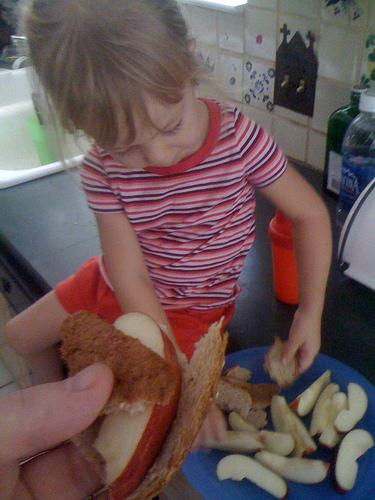Question: when will the girl finish the apples?
Choices:
A. When she's satisfied.
B. After dinner.
C. After school.
D. When her mom reminds her.
Answer with the letter. Answer: A Question: where are the apples?
Choices:
A. On the counter.
B. On the plate.
C. In the bin.
D. On the table.
Answer with the letter. Answer: B Question: who is eating the apples?
Choices:
A. The worms.
B. The pigs.
C. An old woman.
D. A child.
Answer with the letter. Answer: D Question: why are the apples sliced?
Choices:
A. To use in a pie.
B. For a snack.
C. To cook them for an ice cream topping.
D. To remove the bad sections.
Answer with the letter. Answer: B 